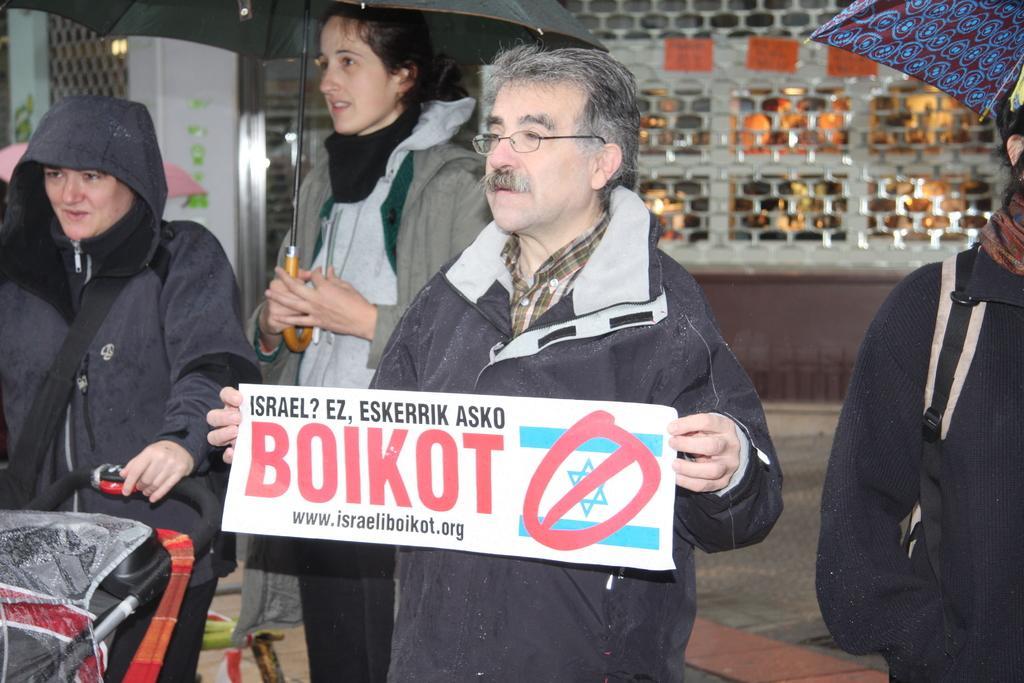Could you give a brief overview of what you see in this image? In this image we can see this person wearing sweater is holding a placard in his hands and these person are holding umbrellas and this person is moving the trolley. In the background, we can see grill shutter. 